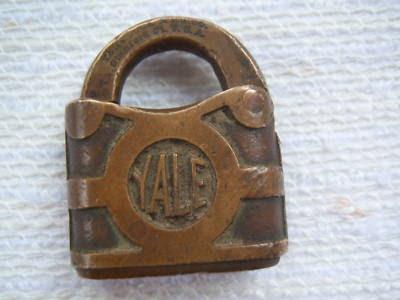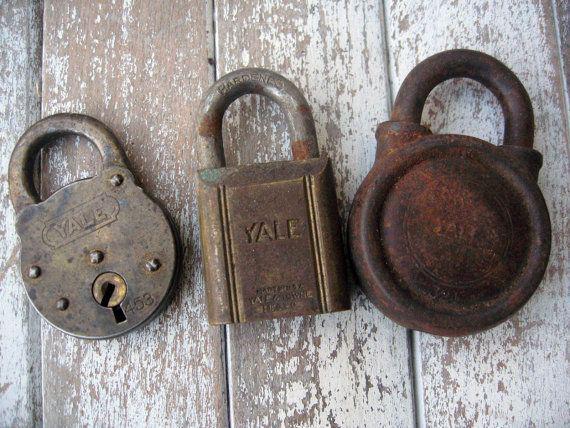The first image is the image on the left, the second image is the image on the right. Evaluate the accuracy of this statement regarding the images: "There are four closed and locked padlocks in total.". Is it true? Answer yes or no. Yes. The first image is the image on the left, the second image is the image on the right. For the images displayed, is the sentence "An image shows three locks of similar style and includes some keys." factually correct? Answer yes or no. No. 